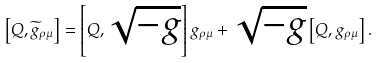<formula> <loc_0><loc_0><loc_500><loc_500>\left [ Q , \widetilde { g } _ { \rho \mu } \right ] = \left [ Q , \sqrt { - g } \right ] g _ { \rho \mu } + \sqrt { - g } \left [ Q , g _ { \rho \mu } \right ] .</formula> 